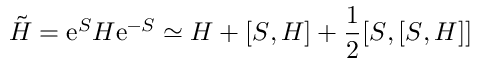<formula> <loc_0><loc_0><loc_500><loc_500>\tilde { H } = e ^ { S } H e ^ { - S } \simeq H + [ S , H ] + \frac { 1 } { 2 } [ S , [ S , H ] ]</formula> 